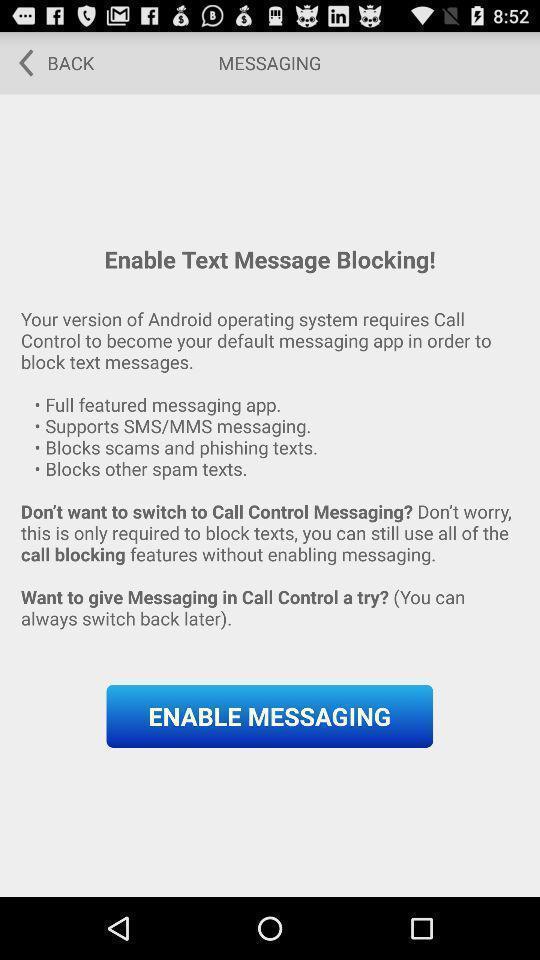Describe the visual elements of this screenshot. Window displaying about message app. 